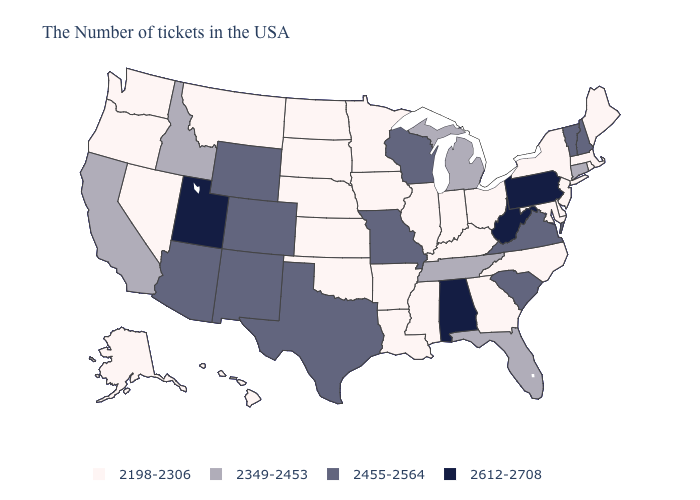Does Florida have the lowest value in the USA?
Short answer required. No. What is the value of Georgia?
Short answer required. 2198-2306. Among the states that border Kentucky , does Illinois have the lowest value?
Give a very brief answer. Yes. Which states have the lowest value in the South?
Short answer required. Delaware, Maryland, North Carolina, Georgia, Kentucky, Mississippi, Louisiana, Arkansas, Oklahoma. What is the value of Kansas?
Be succinct. 2198-2306. What is the value of Indiana?
Write a very short answer. 2198-2306. What is the value of Utah?
Write a very short answer. 2612-2708. Does the first symbol in the legend represent the smallest category?
Quick response, please. Yes. What is the lowest value in the USA?
Be succinct. 2198-2306. Is the legend a continuous bar?
Be succinct. No. What is the highest value in the USA?
Write a very short answer. 2612-2708. Does Utah have the lowest value in the West?
Answer briefly. No. What is the highest value in states that border Maryland?
Give a very brief answer. 2612-2708. Name the states that have a value in the range 2349-2453?
Keep it brief. Connecticut, Florida, Michigan, Tennessee, Idaho, California. Does the map have missing data?
Concise answer only. No. 